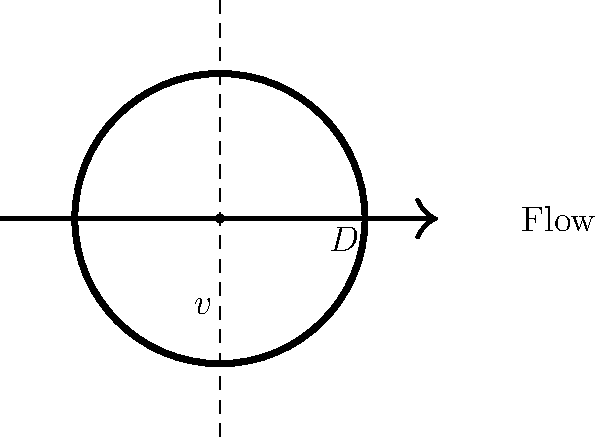As the local oil refinery representative, you need to calculate the flow rate of crude oil through a pipeline. The pipeline has a diameter of 0.5 meters, and the average velocity of the oil is 2 m/s. Given that the density of the crude oil is 850 kg/m³ and its dynamic viscosity is 0.03 Pa·s, determine the volumetric flow rate in m³/s and the Reynolds number for this flow. Is the flow laminar or turbulent? Let's approach this step-by-step:

1) First, calculate the volumetric flow rate (Q):
   Q = A * v, where A is the cross-sectional area of the pipe and v is the velocity.
   A = π * (D/2)² = π * (0.5/2)² = 0.1963 m²
   Q = 0.1963 m² * 2 m/s = 0.3927 m³/s

2) Now, let's calculate the Reynolds number (Re):
   Re = (ρ * v * D) / μ
   Where:
   ρ (rho) = density = 850 kg/m³
   v = velocity = 2 m/s
   D = diameter = 0.5 m
   μ (mu) = dynamic viscosity = 0.03 Pa·s

   Re = (850 * 2 * 0.5) / 0.03 = 28,333.33

3) Determine if the flow is laminar or turbulent:
   - For pipe flow, if Re < 2300, the flow is laminar
   - If Re > 4000, the flow is turbulent
   - Between 2300 and 4000 is the transition region

   Since Re = 28,333.33 > 4000, the flow is turbulent.
Answer: Volumetric flow rate: 0.3927 m³/s; Reynolds number: 28,333.33; Flow is turbulent. 